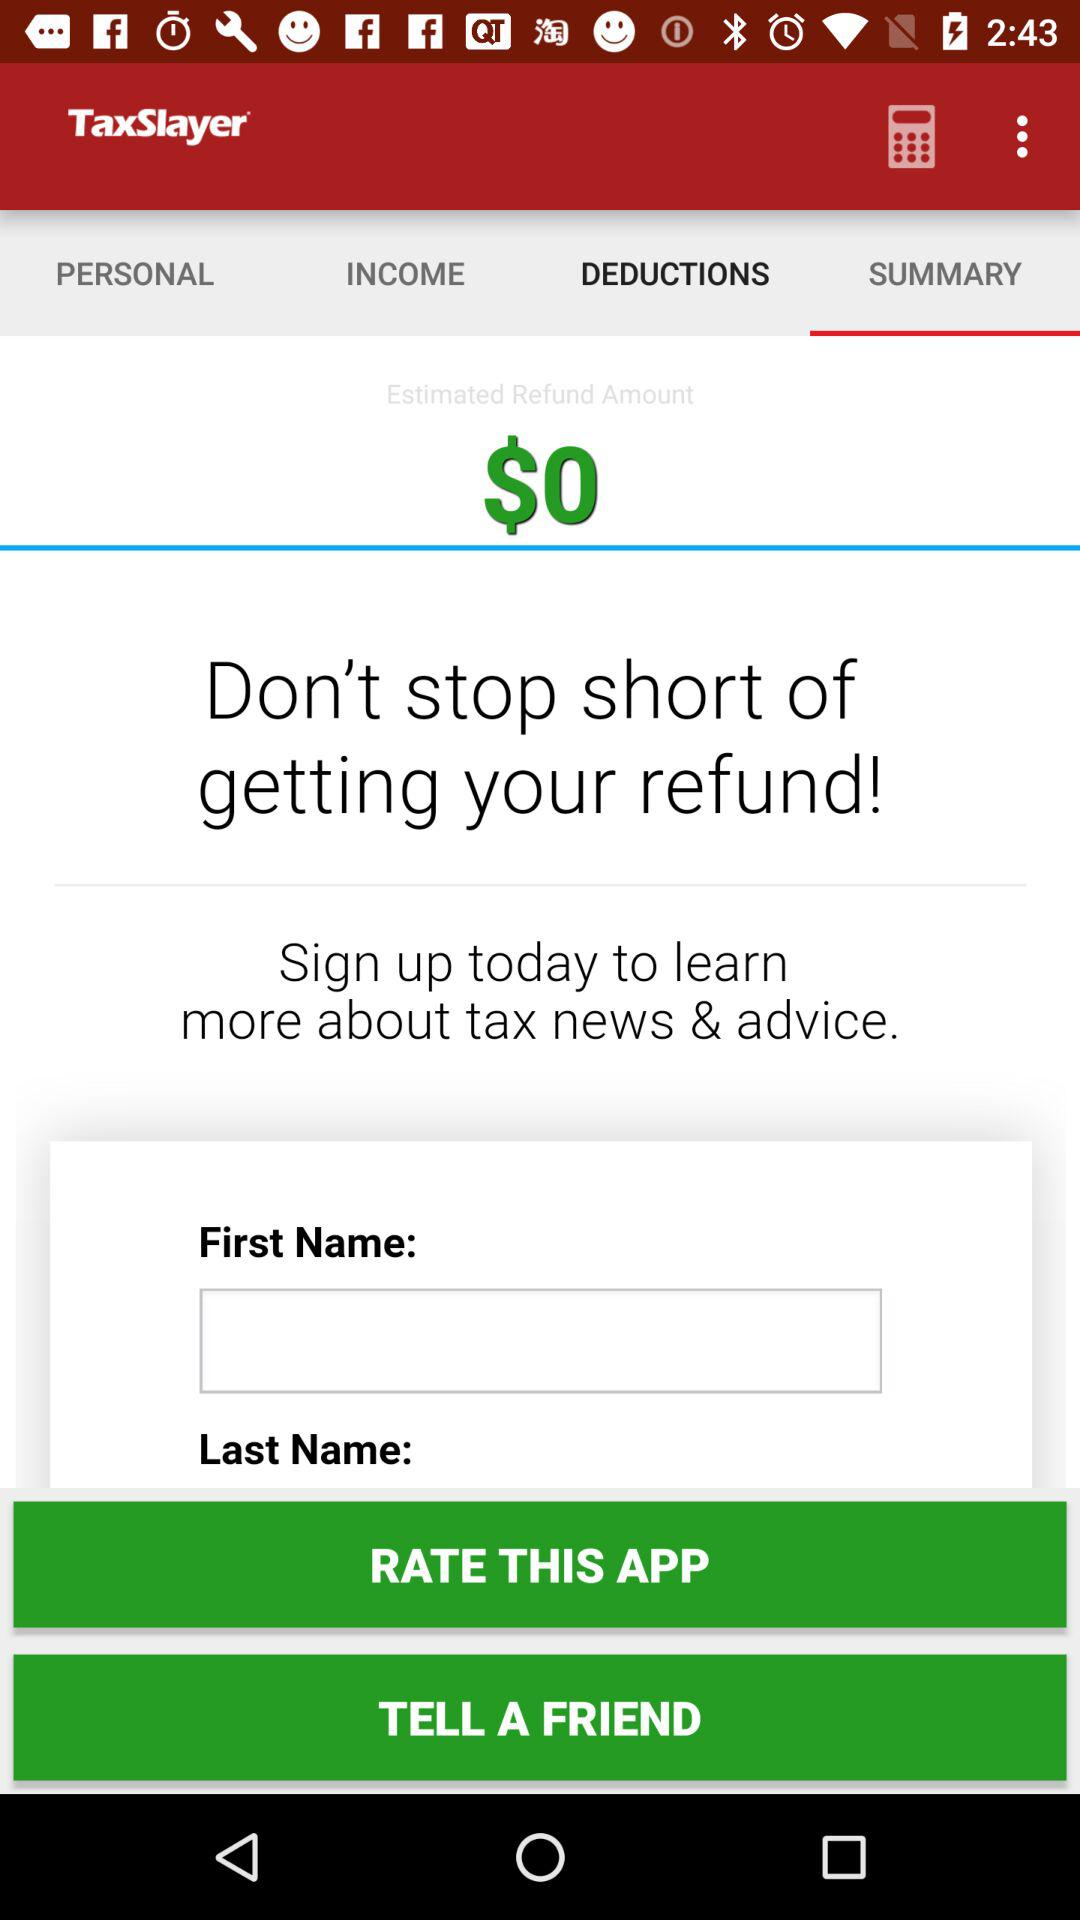What is the name of the application? The name of the application is "TaxSlayer". 